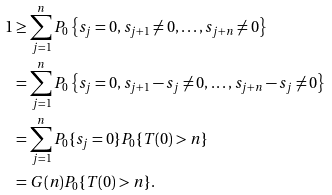<formula> <loc_0><loc_0><loc_500><loc_500>1 & \geq \sum _ { j = 1 } ^ { n } P _ { 0 } \left \{ s _ { j } = 0 , s _ { j + 1 } \neq 0 , \dots , s _ { j + n } \neq 0 \right \} \\ & = \sum _ { j = 1 } ^ { n } P _ { 0 } \left \{ s _ { j } = 0 , s _ { j + 1 } - s _ { j } \neq 0 , \dots , s _ { j + n } - s _ { j } \neq 0 \right \} \\ & = \sum _ { j = 1 } ^ { n } P _ { 0 } \{ s _ { j } = 0 \} P _ { 0 } \{ T ( 0 ) > n \} \\ & = G ( n ) P _ { 0 } \{ T ( 0 ) > n \} .</formula> 